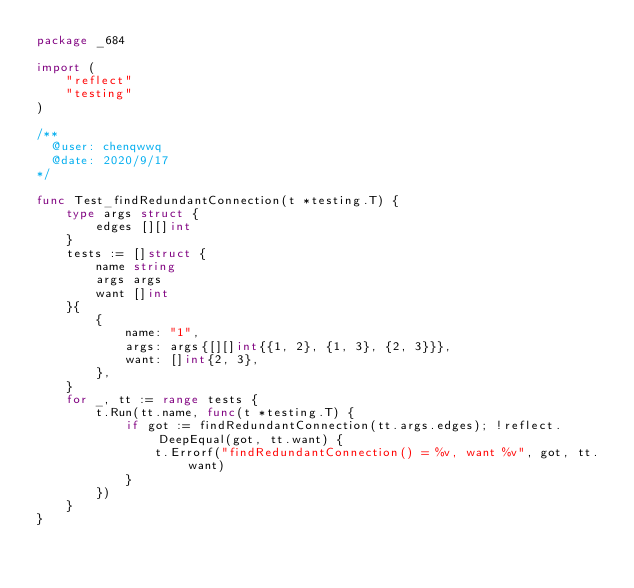<code> <loc_0><loc_0><loc_500><loc_500><_Go_>package _684

import (
	"reflect"
	"testing"
)

/**
  @user: chenqwwq
  @date: 2020/9/17
*/

func Test_findRedundantConnection(t *testing.T) {
	type args struct {
		edges [][]int
	}
	tests := []struct {
		name string
		args args
		want []int
	}{
		{
			name: "1",
			args: args{[][]int{{1, 2}, {1, 3}, {2, 3}}},
			want: []int{2, 3},
		},
	}
	for _, tt := range tests {
		t.Run(tt.name, func(t *testing.T) {
			if got := findRedundantConnection(tt.args.edges); !reflect.DeepEqual(got, tt.want) {
				t.Errorf("findRedundantConnection() = %v, want %v", got, tt.want)
			}
		})
	}
}
</code> 